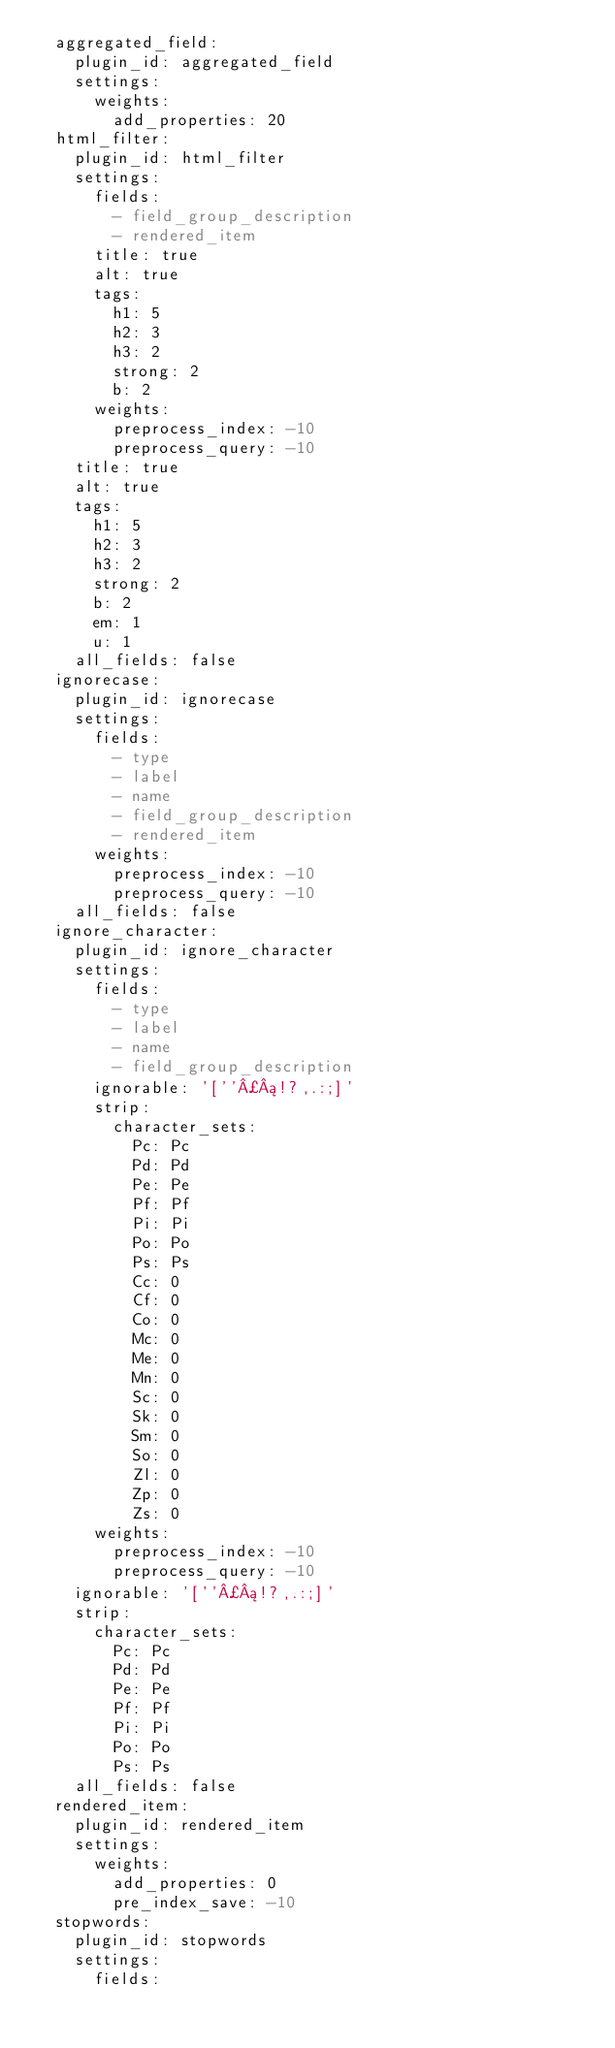Convert code to text. <code><loc_0><loc_0><loc_500><loc_500><_YAML_>  aggregated_field:
    plugin_id: aggregated_field
    settings:
      weights:
        add_properties: 20
  html_filter:
    plugin_id: html_filter
    settings:
      fields:
        - field_group_description
        - rendered_item
      title: true
      alt: true
      tags:
        h1: 5
        h2: 3
        h3: 2
        strong: 2
        b: 2
      weights:
        preprocess_index: -10
        preprocess_query: -10
    title: true
    alt: true
    tags:
      h1: 5
      h2: 3
      h3: 2
      strong: 2
      b: 2
      em: 1
      u: 1
    all_fields: false
  ignorecase:
    plugin_id: ignorecase
    settings:
      fields:
        - type
        - label
        - name
        - field_group_description
        - rendered_item
      weights:
        preprocess_index: -10
        preprocess_query: -10
    all_fields: false
  ignore_character:
    plugin_id: ignore_character
    settings:
      fields:
        - type
        - label
        - name
        - field_group_description
      ignorable: '[''¿¡!?,.:;]'
      strip:
        character_sets:
          Pc: Pc
          Pd: Pd
          Pe: Pe
          Pf: Pf
          Pi: Pi
          Po: Po
          Ps: Ps
          Cc: 0
          Cf: 0
          Co: 0
          Mc: 0
          Me: 0
          Mn: 0
          Sc: 0
          Sk: 0
          Sm: 0
          So: 0
          Zl: 0
          Zp: 0
          Zs: 0
      weights:
        preprocess_index: -10
        preprocess_query: -10
    ignorable: '[''¿¡!?,.:;]'
    strip:
      character_sets:
        Pc: Pc
        Pd: Pd
        Pe: Pe
        Pf: Pf
        Pi: Pi
        Po: Po
        Ps: Ps
    all_fields: false
  rendered_item:
    plugin_id: rendered_item
    settings:
      weights:
        add_properties: 0
        pre_index_save: -10
  stopwords:
    plugin_id: stopwords
    settings:
      fields:</code> 